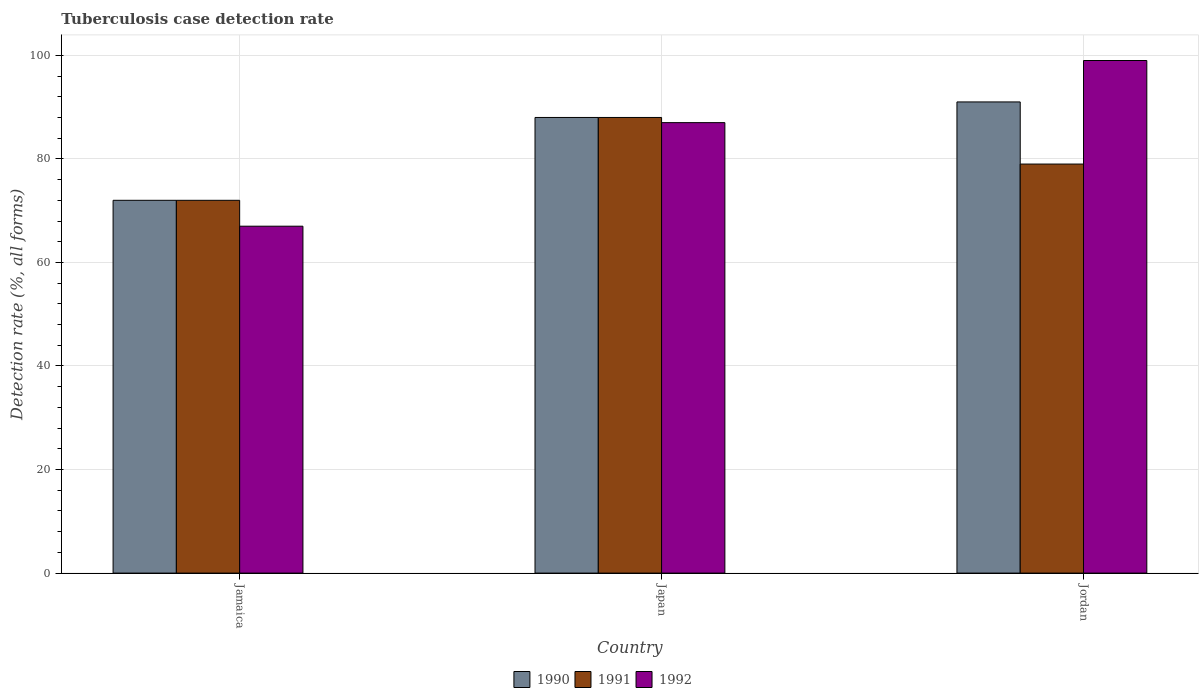Are the number of bars per tick equal to the number of legend labels?
Provide a short and direct response. Yes. Are the number of bars on each tick of the X-axis equal?
Make the answer very short. Yes. How many bars are there on the 1st tick from the right?
Your answer should be compact. 3. In how many cases, is the number of bars for a given country not equal to the number of legend labels?
Keep it short and to the point. 0. What is the tuberculosis case detection rate in in 1992 in Jamaica?
Your response must be concise. 67. In which country was the tuberculosis case detection rate in in 1991 maximum?
Offer a terse response. Japan. In which country was the tuberculosis case detection rate in in 1991 minimum?
Offer a very short reply. Jamaica. What is the total tuberculosis case detection rate in in 1990 in the graph?
Give a very brief answer. 251. What is the average tuberculosis case detection rate in in 1990 per country?
Keep it short and to the point. 83.67. In how many countries, is the tuberculosis case detection rate in in 1990 greater than 28 %?
Provide a short and direct response. 3. What is the ratio of the tuberculosis case detection rate in in 1991 in Jamaica to that in Jordan?
Your answer should be compact. 0.91. Is the tuberculosis case detection rate in in 1992 in Japan less than that in Jordan?
Offer a very short reply. Yes. What is the difference between the highest and the second highest tuberculosis case detection rate in in 1990?
Provide a succinct answer. 16. In how many countries, is the tuberculosis case detection rate in in 1992 greater than the average tuberculosis case detection rate in in 1992 taken over all countries?
Your answer should be very brief. 2. Is the sum of the tuberculosis case detection rate in in 1990 in Japan and Jordan greater than the maximum tuberculosis case detection rate in in 1991 across all countries?
Ensure brevity in your answer.  Yes. What does the 3rd bar from the left in Jordan represents?
Your answer should be very brief. 1992. What does the 1st bar from the right in Jamaica represents?
Make the answer very short. 1992. Are all the bars in the graph horizontal?
Your answer should be very brief. No. How many countries are there in the graph?
Your answer should be very brief. 3. What is the difference between two consecutive major ticks on the Y-axis?
Your answer should be compact. 20. Are the values on the major ticks of Y-axis written in scientific E-notation?
Keep it short and to the point. No. Does the graph contain any zero values?
Provide a short and direct response. No. Does the graph contain grids?
Provide a succinct answer. Yes. What is the title of the graph?
Make the answer very short. Tuberculosis case detection rate. Does "1993" appear as one of the legend labels in the graph?
Provide a short and direct response. No. What is the label or title of the X-axis?
Provide a succinct answer. Country. What is the label or title of the Y-axis?
Ensure brevity in your answer.  Detection rate (%, all forms). What is the Detection rate (%, all forms) of 1990 in Jamaica?
Provide a succinct answer. 72. What is the Detection rate (%, all forms) in 1991 in Jamaica?
Ensure brevity in your answer.  72. What is the Detection rate (%, all forms) in 1992 in Jamaica?
Offer a very short reply. 67. What is the Detection rate (%, all forms) in 1990 in Japan?
Make the answer very short. 88. What is the Detection rate (%, all forms) in 1991 in Japan?
Keep it short and to the point. 88. What is the Detection rate (%, all forms) in 1992 in Japan?
Your answer should be very brief. 87. What is the Detection rate (%, all forms) in 1990 in Jordan?
Make the answer very short. 91. What is the Detection rate (%, all forms) of 1991 in Jordan?
Provide a succinct answer. 79. What is the Detection rate (%, all forms) of 1992 in Jordan?
Ensure brevity in your answer.  99. Across all countries, what is the maximum Detection rate (%, all forms) in 1990?
Make the answer very short. 91. Across all countries, what is the maximum Detection rate (%, all forms) of 1991?
Make the answer very short. 88. Across all countries, what is the maximum Detection rate (%, all forms) in 1992?
Provide a succinct answer. 99. What is the total Detection rate (%, all forms) of 1990 in the graph?
Your response must be concise. 251. What is the total Detection rate (%, all forms) of 1991 in the graph?
Give a very brief answer. 239. What is the total Detection rate (%, all forms) in 1992 in the graph?
Provide a short and direct response. 253. What is the difference between the Detection rate (%, all forms) in 1990 in Jamaica and that in Japan?
Give a very brief answer. -16. What is the difference between the Detection rate (%, all forms) in 1991 in Jamaica and that in Japan?
Provide a short and direct response. -16. What is the difference between the Detection rate (%, all forms) in 1990 in Jamaica and that in Jordan?
Give a very brief answer. -19. What is the difference between the Detection rate (%, all forms) in 1991 in Jamaica and that in Jordan?
Keep it short and to the point. -7. What is the difference between the Detection rate (%, all forms) in 1992 in Jamaica and that in Jordan?
Provide a short and direct response. -32. What is the difference between the Detection rate (%, all forms) of 1990 in Japan and that in Jordan?
Make the answer very short. -3. What is the difference between the Detection rate (%, all forms) in 1991 in Japan and that in Jordan?
Provide a succinct answer. 9. What is the difference between the Detection rate (%, all forms) of 1990 in Jamaica and the Detection rate (%, all forms) of 1992 in Japan?
Make the answer very short. -15. What is the difference between the Detection rate (%, all forms) of 1991 in Jamaica and the Detection rate (%, all forms) of 1992 in Jordan?
Your answer should be very brief. -27. What is the difference between the Detection rate (%, all forms) in 1990 in Japan and the Detection rate (%, all forms) in 1991 in Jordan?
Your response must be concise. 9. What is the difference between the Detection rate (%, all forms) in 1991 in Japan and the Detection rate (%, all forms) in 1992 in Jordan?
Your response must be concise. -11. What is the average Detection rate (%, all forms) in 1990 per country?
Ensure brevity in your answer.  83.67. What is the average Detection rate (%, all forms) in 1991 per country?
Provide a succinct answer. 79.67. What is the average Detection rate (%, all forms) of 1992 per country?
Your response must be concise. 84.33. What is the difference between the Detection rate (%, all forms) of 1990 and Detection rate (%, all forms) of 1991 in Jamaica?
Provide a short and direct response. 0. What is the difference between the Detection rate (%, all forms) of 1990 and Detection rate (%, all forms) of 1991 in Japan?
Offer a terse response. 0. What is the difference between the Detection rate (%, all forms) in 1990 and Detection rate (%, all forms) in 1992 in Japan?
Ensure brevity in your answer.  1. What is the difference between the Detection rate (%, all forms) of 1990 and Detection rate (%, all forms) of 1991 in Jordan?
Ensure brevity in your answer.  12. What is the difference between the Detection rate (%, all forms) of 1990 and Detection rate (%, all forms) of 1992 in Jordan?
Provide a short and direct response. -8. What is the difference between the Detection rate (%, all forms) of 1991 and Detection rate (%, all forms) of 1992 in Jordan?
Make the answer very short. -20. What is the ratio of the Detection rate (%, all forms) of 1990 in Jamaica to that in Japan?
Offer a very short reply. 0.82. What is the ratio of the Detection rate (%, all forms) in 1991 in Jamaica to that in Japan?
Provide a succinct answer. 0.82. What is the ratio of the Detection rate (%, all forms) of 1992 in Jamaica to that in Japan?
Give a very brief answer. 0.77. What is the ratio of the Detection rate (%, all forms) of 1990 in Jamaica to that in Jordan?
Provide a succinct answer. 0.79. What is the ratio of the Detection rate (%, all forms) in 1991 in Jamaica to that in Jordan?
Provide a short and direct response. 0.91. What is the ratio of the Detection rate (%, all forms) in 1992 in Jamaica to that in Jordan?
Offer a very short reply. 0.68. What is the ratio of the Detection rate (%, all forms) in 1991 in Japan to that in Jordan?
Provide a short and direct response. 1.11. What is the ratio of the Detection rate (%, all forms) of 1992 in Japan to that in Jordan?
Your answer should be very brief. 0.88. What is the difference between the highest and the second highest Detection rate (%, all forms) in 1992?
Offer a terse response. 12. What is the difference between the highest and the lowest Detection rate (%, all forms) in 1990?
Your answer should be compact. 19. 